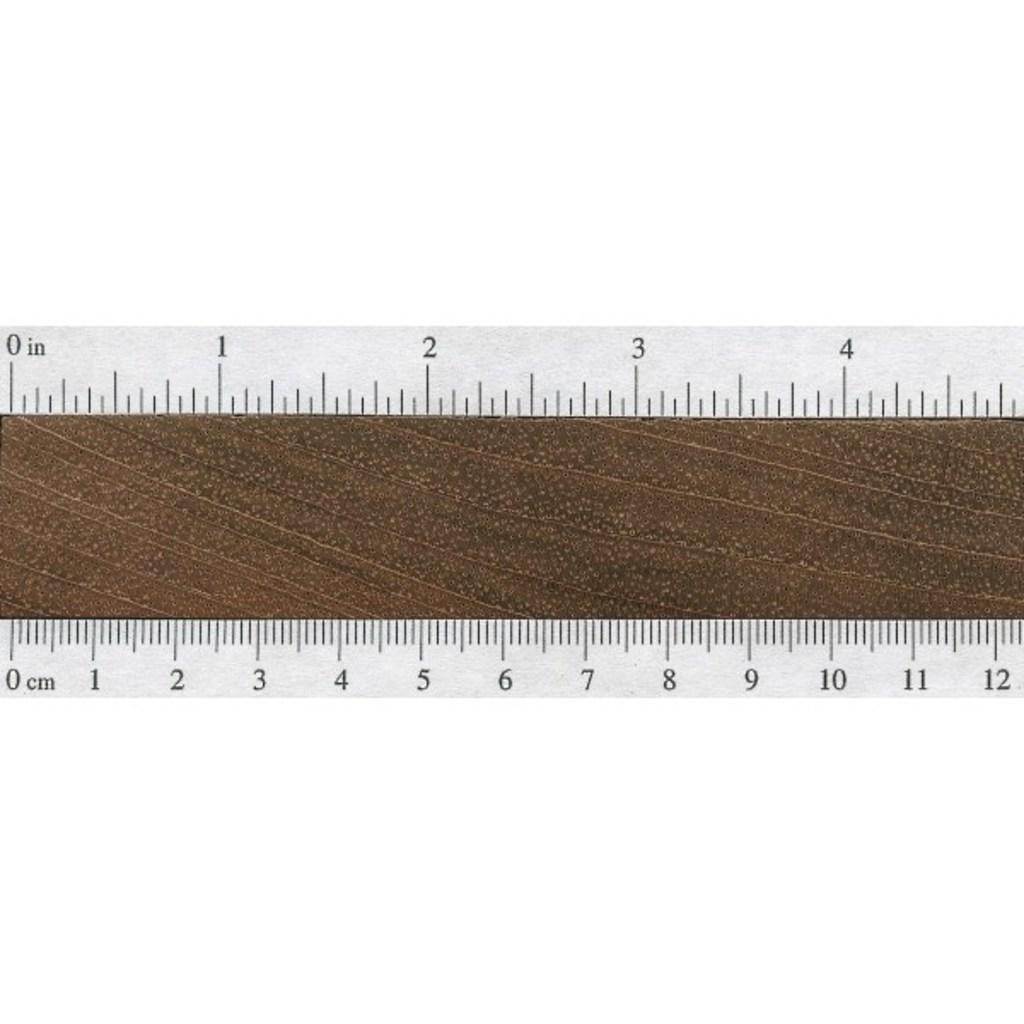Provide a one-sentence caption for the provided image. A ruler with inches on the top and centimetres on the bottom. 